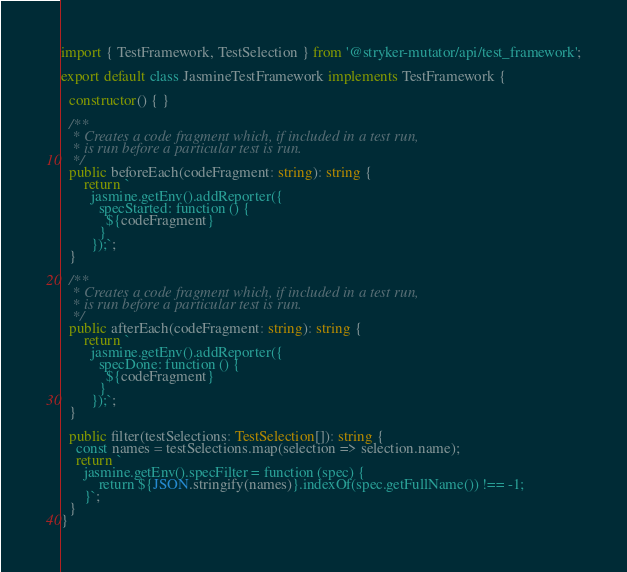<code> <loc_0><loc_0><loc_500><loc_500><_TypeScript_>import { TestFramework, TestSelection } from '@stryker-mutator/api/test_framework';

export default class JasmineTestFramework implements TestFramework {

  constructor() { }

  /**
   * Creates a code fragment which, if included in a test run,
   * is run before a particular test is run.
   */
  public beforeEach(codeFragment: string): string {
      return `
        jasmine.getEnv().addReporter({
          specStarted: function () {
            ${codeFragment}
          }
        });`;
  }

  /**
   * Creates a code fragment which, if included in a test run,
   * is run before a particular test is run.
   */
  public afterEach(codeFragment: string): string {
      return `
        jasmine.getEnv().addReporter({
          specDone: function () {
            ${codeFragment}
          }
        });`;
  }

  public filter(testSelections: TestSelection[]): string {
    const names = testSelections.map(selection => selection.name);
    return `
      jasmine.getEnv().specFilter = function (spec) {
          return ${JSON.stringify(names)}.indexOf(spec.getFullName()) !== -1;
      }`;
  }
}
</code> 